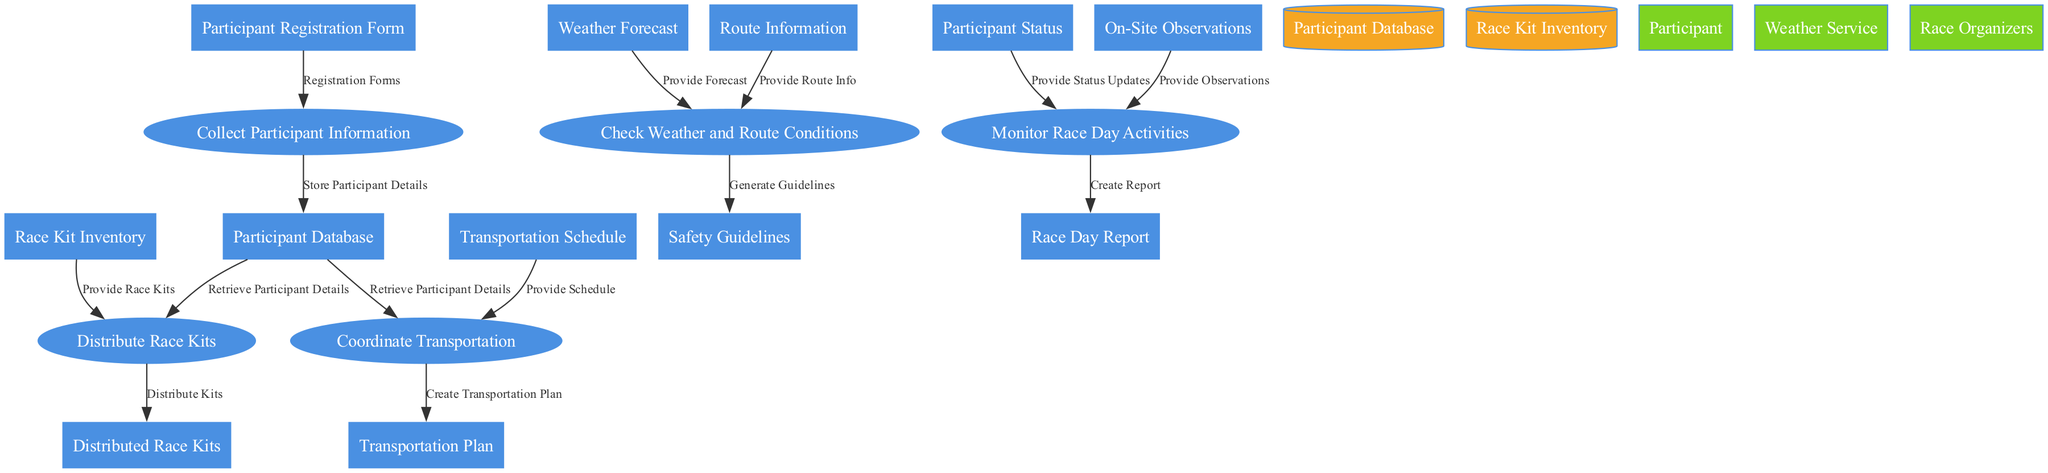What is the first process in the diagram? The first process listed in the diagram is "Collect Participant Information," which is identified by the ID P1. It represents the starting point of collecting data related to participants for the race.
Answer: Collect Participant Information How many processes are there in total? The diagram lists five processes, including collecting participant information, distributing race kits, coordinating transportation, checking weather and route conditions, and monitoring race day activities. This can be counted from the provided list of processes.
Answer: Five What data store is related to race kits? The race kits are managed within the "Race Kit Inventory," as the diagram shows this data store receiving inputs related to race kits for distribution.
Answer: Race Kit Inventory Which external entity provides weather forecasts? The external entity responsible for providing weather forecasts is the "Weather Service," identified in the diagram as E2. The output related to this entity is the weather forecast used in the process of checking conditions.
Answer: Weather Service What are the outputs of the process "Check Weather and Route Conditions"? The output of the process "Check Weather and Route Conditions" is the "Safety Guidelines," which are generated based on the weather forecast and route information provided to the process.
Answer: Safety Guidelines What input is needed for the process "Distribute Race Kits"? The process "Distribute Race Kits" requires two inputs: "Participant Details" and "Race Kits." These inputs are necessary for properly managing the distribution of race kits to participants.
Answer: Participant Details and Race Kits What is created from the "Monitor Race Day Activities" process? The "Monitor Race Day Activities" process produces the output called "Race Day Report," which summarizes the observations and status updates collected during the event.
Answer: Race Day Report What is the relationship between "Participant Registration Form" and "Store Participant Details"? The "Participant Registration Form" serves as an input to the process responsible for "Store Participant Details," indicating that the participant registration form data is utilized to store details in the participant database.
Answer: Is an input How many data flows connect to the "Participant Database"? There are three data flows connected to the "Participant Database": one for storing participant details, one for retrieving participant details for race kit distribution, and one for retrieving participant details for transportation coordination. This can be verified in the data flow section.
Answer: Three Which process uses both "Participant Status" and "On-Site Observations"? The process that uses both "Participant Status" and "On-Site Observations" is "Monitor Race Day Activities." This process handles both inputs to create a comprehensive report on race day activities.
Answer: Monitor Race Day Activities 